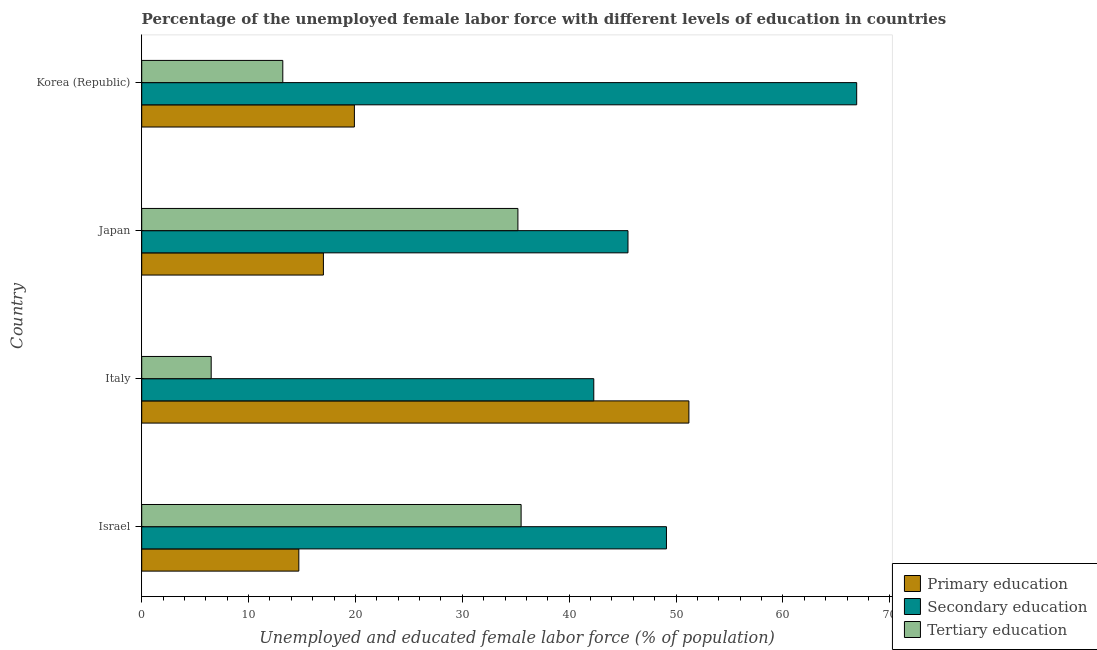How many groups of bars are there?
Keep it short and to the point. 4. Are the number of bars on each tick of the Y-axis equal?
Your response must be concise. Yes. What is the percentage of female labor force who received tertiary education in Israel?
Provide a short and direct response. 35.5. Across all countries, what is the maximum percentage of female labor force who received primary education?
Your answer should be compact. 51.2. Across all countries, what is the minimum percentage of female labor force who received primary education?
Your answer should be very brief. 14.7. In which country was the percentage of female labor force who received secondary education maximum?
Give a very brief answer. Korea (Republic). What is the total percentage of female labor force who received tertiary education in the graph?
Your answer should be compact. 90.4. What is the difference between the percentage of female labor force who received tertiary education in Japan and that in Korea (Republic)?
Your answer should be very brief. 22. What is the difference between the percentage of female labor force who received tertiary education in Korea (Republic) and the percentage of female labor force who received primary education in Israel?
Provide a succinct answer. -1.5. What is the average percentage of female labor force who received primary education per country?
Keep it short and to the point. 25.7. What is the difference between the percentage of female labor force who received secondary education and percentage of female labor force who received tertiary education in Israel?
Provide a short and direct response. 13.6. In how many countries, is the percentage of female labor force who received tertiary education greater than 16 %?
Give a very brief answer. 2. What is the ratio of the percentage of female labor force who received secondary education in Japan to that in Korea (Republic)?
Your answer should be very brief. 0.68. Is the difference between the percentage of female labor force who received primary education in Israel and Korea (Republic) greater than the difference between the percentage of female labor force who received tertiary education in Israel and Korea (Republic)?
Give a very brief answer. No. What is the difference between the highest and the second highest percentage of female labor force who received tertiary education?
Make the answer very short. 0.3. What is the difference between the highest and the lowest percentage of female labor force who received primary education?
Provide a succinct answer. 36.5. What does the 2nd bar from the top in Japan represents?
Your response must be concise. Secondary education. What does the 3rd bar from the bottom in Italy represents?
Make the answer very short. Tertiary education. How many countries are there in the graph?
Your answer should be very brief. 4. Does the graph contain grids?
Give a very brief answer. No. What is the title of the graph?
Offer a very short reply. Percentage of the unemployed female labor force with different levels of education in countries. What is the label or title of the X-axis?
Offer a very short reply. Unemployed and educated female labor force (% of population). What is the label or title of the Y-axis?
Your answer should be compact. Country. What is the Unemployed and educated female labor force (% of population) of Primary education in Israel?
Keep it short and to the point. 14.7. What is the Unemployed and educated female labor force (% of population) in Secondary education in Israel?
Provide a short and direct response. 49.1. What is the Unemployed and educated female labor force (% of population) in Tertiary education in Israel?
Give a very brief answer. 35.5. What is the Unemployed and educated female labor force (% of population) of Primary education in Italy?
Provide a short and direct response. 51.2. What is the Unemployed and educated female labor force (% of population) in Secondary education in Italy?
Offer a terse response. 42.3. What is the Unemployed and educated female labor force (% of population) of Tertiary education in Italy?
Your answer should be very brief. 6.5. What is the Unemployed and educated female labor force (% of population) of Primary education in Japan?
Give a very brief answer. 17. What is the Unemployed and educated female labor force (% of population) in Secondary education in Japan?
Provide a succinct answer. 45.5. What is the Unemployed and educated female labor force (% of population) in Tertiary education in Japan?
Offer a terse response. 35.2. What is the Unemployed and educated female labor force (% of population) in Primary education in Korea (Republic)?
Make the answer very short. 19.9. What is the Unemployed and educated female labor force (% of population) of Secondary education in Korea (Republic)?
Your answer should be compact. 66.9. What is the Unemployed and educated female labor force (% of population) in Tertiary education in Korea (Republic)?
Offer a terse response. 13.2. Across all countries, what is the maximum Unemployed and educated female labor force (% of population) in Primary education?
Provide a succinct answer. 51.2. Across all countries, what is the maximum Unemployed and educated female labor force (% of population) in Secondary education?
Your response must be concise. 66.9. Across all countries, what is the maximum Unemployed and educated female labor force (% of population) of Tertiary education?
Your answer should be very brief. 35.5. Across all countries, what is the minimum Unemployed and educated female labor force (% of population) in Primary education?
Keep it short and to the point. 14.7. Across all countries, what is the minimum Unemployed and educated female labor force (% of population) of Secondary education?
Offer a terse response. 42.3. What is the total Unemployed and educated female labor force (% of population) of Primary education in the graph?
Your response must be concise. 102.8. What is the total Unemployed and educated female labor force (% of population) of Secondary education in the graph?
Offer a very short reply. 203.8. What is the total Unemployed and educated female labor force (% of population) of Tertiary education in the graph?
Offer a very short reply. 90.4. What is the difference between the Unemployed and educated female labor force (% of population) of Primary education in Israel and that in Italy?
Offer a very short reply. -36.5. What is the difference between the Unemployed and educated female labor force (% of population) of Secondary education in Israel and that in Italy?
Ensure brevity in your answer.  6.8. What is the difference between the Unemployed and educated female labor force (% of population) in Tertiary education in Israel and that in Italy?
Your response must be concise. 29. What is the difference between the Unemployed and educated female labor force (% of population) of Primary education in Israel and that in Japan?
Give a very brief answer. -2.3. What is the difference between the Unemployed and educated female labor force (% of population) in Tertiary education in Israel and that in Japan?
Give a very brief answer. 0.3. What is the difference between the Unemployed and educated female labor force (% of population) of Primary education in Israel and that in Korea (Republic)?
Your answer should be very brief. -5.2. What is the difference between the Unemployed and educated female labor force (% of population) in Secondary education in Israel and that in Korea (Republic)?
Your response must be concise. -17.8. What is the difference between the Unemployed and educated female labor force (% of population) of Tertiary education in Israel and that in Korea (Republic)?
Offer a terse response. 22.3. What is the difference between the Unemployed and educated female labor force (% of population) of Primary education in Italy and that in Japan?
Your answer should be compact. 34.2. What is the difference between the Unemployed and educated female labor force (% of population) in Tertiary education in Italy and that in Japan?
Make the answer very short. -28.7. What is the difference between the Unemployed and educated female labor force (% of population) in Primary education in Italy and that in Korea (Republic)?
Provide a succinct answer. 31.3. What is the difference between the Unemployed and educated female labor force (% of population) in Secondary education in Italy and that in Korea (Republic)?
Your answer should be very brief. -24.6. What is the difference between the Unemployed and educated female labor force (% of population) of Tertiary education in Italy and that in Korea (Republic)?
Provide a short and direct response. -6.7. What is the difference between the Unemployed and educated female labor force (% of population) in Primary education in Japan and that in Korea (Republic)?
Provide a succinct answer. -2.9. What is the difference between the Unemployed and educated female labor force (% of population) in Secondary education in Japan and that in Korea (Republic)?
Ensure brevity in your answer.  -21.4. What is the difference between the Unemployed and educated female labor force (% of population) of Primary education in Israel and the Unemployed and educated female labor force (% of population) of Secondary education in Italy?
Make the answer very short. -27.6. What is the difference between the Unemployed and educated female labor force (% of population) of Secondary education in Israel and the Unemployed and educated female labor force (% of population) of Tertiary education in Italy?
Provide a succinct answer. 42.6. What is the difference between the Unemployed and educated female labor force (% of population) in Primary education in Israel and the Unemployed and educated female labor force (% of population) in Secondary education in Japan?
Make the answer very short. -30.8. What is the difference between the Unemployed and educated female labor force (% of population) in Primary education in Israel and the Unemployed and educated female labor force (% of population) in Tertiary education in Japan?
Keep it short and to the point. -20.5. What is the difference between the Unemployed and educated female labor force (% of population) of Secondary education in Israel and the Unemployed and educated female labor force (% of population) of Tertiary education in Japan?
Provide a short and direct response. 13.9. What is the difference between the Unemployed and educated female labor force (% of population) of Primary education in Israel and the Unemployed and educated female labor force (% of population) of Secondary education in Korea (Republic)?
Offer a terse response. -52.2. What is the difference between the Unemployed and educated female labor force (% of population) of Secondary education in Israel and the Unemployed and educated female labor force (% of population) of Tertiary education in Korea (Republic)?
Provide a short and direct response. 35.9. What is the difference between the Unemployed and educated female labor force (% of population) of Primary education in Italy and the Unemployed and educated female labor force (% of population) of Tertiary education in Japan?
Keep it short and to the point. 16. What is the difference between the Unemployed and educated female labor force (% of population) in Primary education in Italy and the Unemployed and educated female labor force (% of population) in Secondary education in Korea (Republic)?
Your answer should be compact. -15.7. What is the difference between the Unemployed and educated female labor force (% of population) of Primary education in Italy and the Unemployed and educated female labor force (% of population) of Tertiary education in Korea (Republic)?
Your response must be concise. 38. What is the difference between the Unemployed and educated female labor force (% of population) in Secondary education in Italy and the Unemployed and educated female labor force (% of population) in Tertiary education in Korea (Republic)?
Give a very brief answer. 29.1. What is the difference between the Unemployed and educated female labor force (% of population) of Primary education in Japan and the Unemployed and educated female labor force (% of population) of Secondary education in Korea (Republic)?
Give a very brief answer. -49.9. What is the difference between the Unemployed and educated female labor force (% of population) in Secondary education in Japan and the Unemployed and educated female labor force (% of population) in Tertiary education in Korea (Republic)?
Your answer should be compact. 32.3. What is the average Unemployed and educated female labor force (% of population) in Primary education per country?
Your answer should be very brief. 25.7. What is the average Unemployed and educated female labor force (% of population) in Secondary education per country?
Your answer should be very brief. 50.95. What is the average Unemployed and educated female labor force (% of population) in Tertiary education per country?
Provide a short and direct response. 22.6. What is the difference between the Unemployed and educated female labor force (% of population) in Primary education and Unemployed and educated female labor force (% of population) in Secondary education in Israel?
Offer a very short reply. -34.4. What is the difference between the Unemployed and educated female labor force (% of population) in Primary education and Unemployed and educated female labor force (% of population) in Tertiary education in Israel?
Offer a very short reply. -20.8. What is the difference between the Unemployed and educated female labor force (% of population) in Secondary education and Unemployed and educated female labor force (% of population) in Tertiary education in Israel?
Offer a very short reply. 13.6. What is the difference between the Unemployed and educated female labor force (% of population) in Primary education and Unemployed and educated female labor force (% of population) in Tertiary education in Italy?
Make the answer very short. 44.7. What is the difference between the Unemployed and educated female labor force (% of population) of Secondary education and Unemployed and educated female labor force (% of population) of Tertiary education in Italy?
Make the answer very short. 35.8. What is the difference between the Unemployed and educated female labor force (% of population) of Primary education and Unemployed and educated female labor force (% of population) of Secondary education in Japan?
Ensure brevity in your answer.  -28.5. What is the difference between the Unemployed and educated female labor force (% of population) of Primary education and Unemployed and educated female labor force (% of population) of Tertiary education in Japan?
Provide a short and direct response. -18.2. What is the difference between the Unemployed and educated female labor force (% of population) of Primary education and Unemployed and educated female labor force (% of population) of Secondary education in Korea (Republic)?
Your answer should be very brief. -47. What is the difference between the Unemployed and educated female labor force (% of population) in Primary education and Unemployed and educated female labor force (% of population) in Tertiary education in Korea (Republic)?
Provide a short and direct response. 6.7. What is the difference between the Unemployed and educated female labor force (% of population) of Secondary education and Unemployed and educated female labor force (% of population) of Tertiary education in Korea (Republic)?
Provide a short and direct response. 53.7. What is the ratio of the Unemployed and educated female labor force (% of population) in Primary education in Israel to that in Italy?
Give a very brief answer. 0.29. What is the ratio of the Unemployed and educated female labor force (% of population) in Secondary education in Israel to that in Italy?
Offer a very short reply. 1.16. What is the ratio of the Unemployed and educated female labor force (% of population) in Tertiary education in Israel to that in Italy?
Keep it short and to the point. 5.46. What is the ratio of the Unemployed and educated female labor force (% of population) in Primary education in Israel to that in Japan?
Offer a terse response. 0.86. What is the ratio of the Unemployed and educated female labor force (% of population) in Secondary education in Israel to that in Japan?
Your answer should be very brief. 1.08. What is the ratio of the Unemployed and educated female labor force (% of population) of Tertiary education in Israel to that in Japan?
Keep it short and to the point. 1.01. What is the ratio of the Unemployed and educated female labor force (% of population) of Primary education in Israel to that in Korea (Republic)?
Your answer should be very brief. 0.74. What is the ratio of the Unemployed and educated female labor force (% of population) in Secondary education in Israel to that in Korea (Republic)?
Your answer should be compact. 0.73. What is the ratio of the Unemployed and educated female labor force (% of population) of Tertiary education in Israel to that in Korea (Republic)?
Offer a very short reply. 2.69. What is the ratio of the Unemployed and educated female labor force (% of population) in Primary education in Italy to that in Japan?
Your response must be concise. 3.01. What is the ratio of the Unemployed and educated female labor force (% of population) of Secondary education in Italy to that in Japan?
Offer a very short reply. 0.93. What is the ratio of the Unemployed and educated female labor force (% of population) in Tertiary education in Italy to that in Japan?
Your response must be concise. 0.18. What is the ratio of the Unemployed and educated female labor force (% of population) in Primary education in Italy to that in Korea (Republic)?
Your response must be concise. 2.57. What is the ratio of the Unemployed and educated female labor force (% of population) in Secondary education in Italy to that in Korea (Republic)?
Your answer should be compact. 0.63. What is the ratio of the Unemployed and educated female labor force (% of population) of Tertiary education in Italy to that in Korea (Republic)?
Offer a terse response. 0.49. What is the ratio of the Unemployed and educated female labor force (% of population) in Primary education in Japan to that in Korea (Republic)?
Offer a terse response. 0.85. What is the ratio of the Unemployed and educated female labor force (% of population) of Secondary education in Japan to that in Korea (Republic)?
Your response must be concise. 0.68. What is the ratio of the Unemployed and educated female labor force (% of population) of Tertiary education in Japan to that in Korea (Republic)?
Provide a short and direct response. 2.67. What is the difference between the highest and the second highest Unemployed and educated female labor force (% of population) of Primary education?
Your answer should be compact. 31.3. What is the difference between the highest and the second highest Unemployed and educated female labor force (% of population) in Secondary education?
Your answer should be very brief. 17.8. What is the difference between the highest and the second highest Unemployed and educated female labor force (% of population) in Tertiary education?
Your response must be concise. 0.3. What is the difference between the highest and the lowest Unemployed and educated female labor force (% of population) of Primary education?
Provide a short and direct response. 36.5. What is the difference between the highest and the lowest Unemployed and educated female labor force (% of population) in Secondary education?
Your response must be concise. 24.6. 